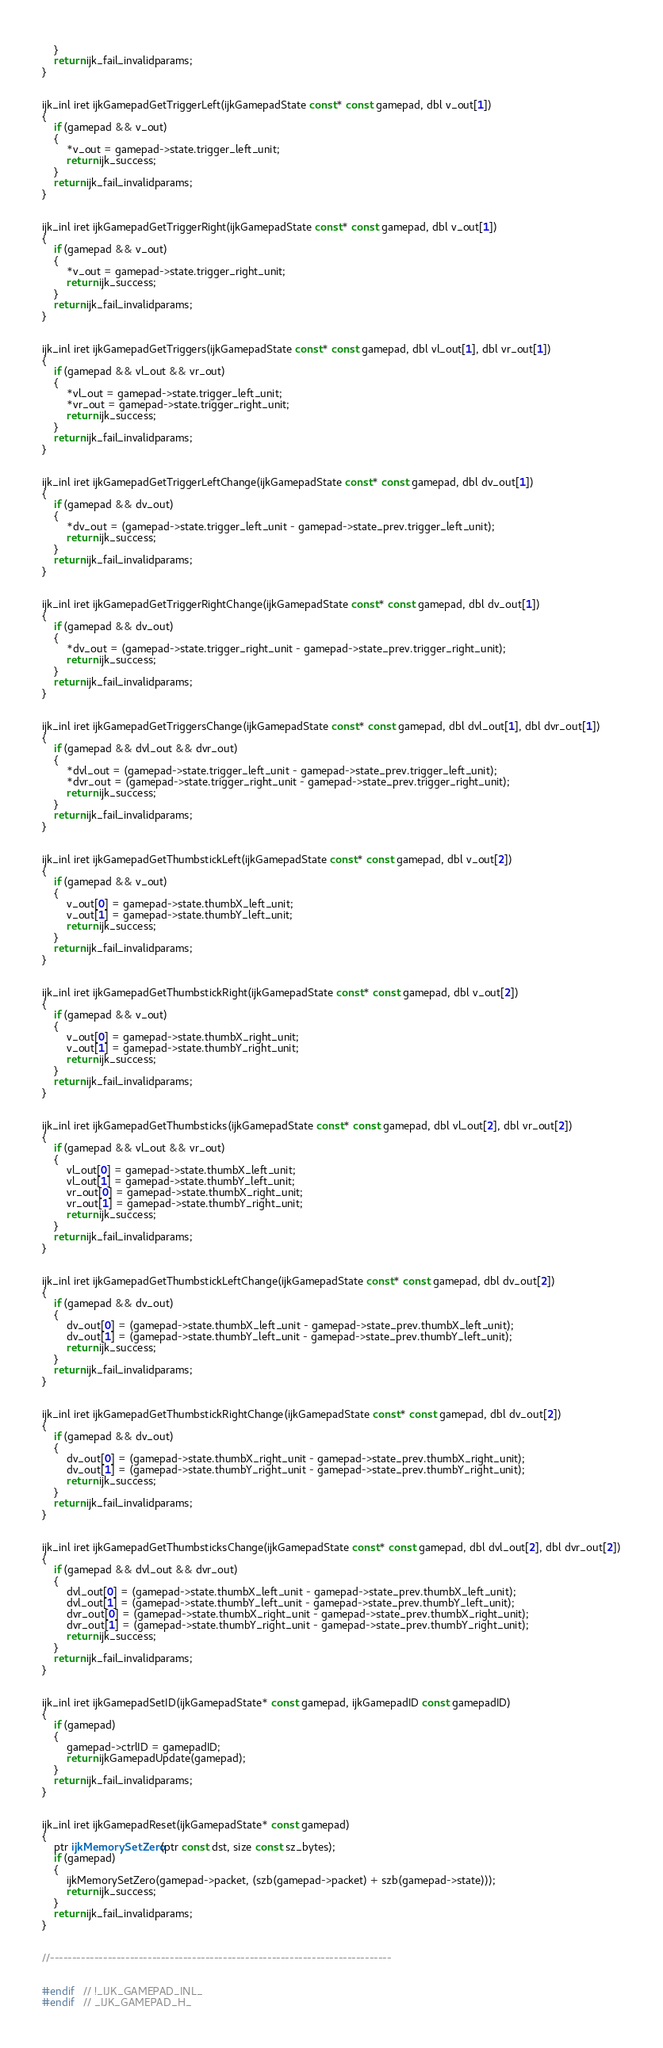<code> <loc_0><loc_0><loc_500><loc_500><_C++_>	}
	return ijk_fail_invalidparams;
}


ijk_inl iret ijkGamepadGetTriggerLeft(ijkGamepadState const* const gamepad, dbl v_out[1])
{
	if (gamepad && v_out)
	{
		*v_out = gamepad->state.trigger_left_unit;
		return ijk_success;
	}
	return ijk_fail_invalidparams;
}


ijk_inl iret ijkGamepadGetTriggerRight(ijkGamepadState const* const gamepad, dbl v_out[1])
{
	if (gamepad && v_out)
	{
		*v_out = gamepad->state.trigger_right_unit;
		return ijk_success;
	}
	return ijk_fail_invalidparams;
}


ijk_inl iret ijkGamepadGetTriggers(ijkGamepadState const* const gamepad, dbl vl_out[1], dbl vr_out[1])
{
	if (gamepad && vl_out && vr_out)
	{
		*vl_out = gamepad->state.trigger_left_unit;
		*vr_out = gamepad->state.trigger_right_unit;
		return ijk_success;
	}
	return ijk_fail_invalidparams;
}


ijk_inl iret ijkGamepadGetTriggerLeftChange(ijkGamepadState const* const gamepad, dbl dv_out[1])
{
	if (gamepad && dv_out)
	{
		*dv_out = (gamepad->state.trigger_left_unit - gamepad->state_prev.trigger_left_unit);
		return ijk_success;
	}
	return ijk_fail_invalidparams;
}


ijk_inl iret ijkGamepadGetTriggerRightChange(ijkGamepadState const* const gamepad, dbl dv_out[1])
{
	if (gamepad && dv_out)
	{
		*dv_out = (gamepad->state.trigger_right_unit - gamepad->state_prev.trigger_right_unit);
		return ijk_success;
	}
	return ijk_fail_invalidparams;
}


ijk_inl iret ijkGamepadGetTriggersChange(ijkGamepadState const* const gamepad, dbl dvl_out[1], dbl dvr_out[1])
{
	if (gamepad && dvl_out && dvr_out)
	{
		*dvl_out = (gamepad->state.trigger_left_unit - gamepad->state_prev.trigger_left_unit);
		*dvr_out = (gamepad->state.trigger_right_unit - gamepad->state_prev.trigger_right_unit);
		return ijk_success;
	}
	return ijk_fail_invalidparams;
}


ijk_inl iret ijkGamepadGetThumbstickLeft(ijkGamepadState const* const gamepad, dbl v_out[2])
{
	if (gamepad && v_out)
	{
		v_out[0] = gamepad->state.thumbX_left_unit;
		v_out[1] = gamepad->state.thumbY_left_unit;
		return ijk_success;
	}
	return ijk_fail_invalidparams;
}


ijk_inl iret ijkGamepadGetThumbstickRight(ijkGamepadState const* const gamepad, dbl v_out[2])
{
	if (gamepad && v_out)
	{
		v_out[0] = gamepad->state.thumbX_right_unit;
		v_out[1] = gamepad->state.thumbY_right_unit;
		return ijk_success;
	}
	return ijk_fail_invalidparams;
}


ijk_inl iret ijkGamepadGetThumbsticks(ijkGamepadState const* const gamepad, dbl vl_out[2], dbl vr_out[2])
{
	if (gamepad && vl_out && vr_out)
	{
		vl_out[0] = gamepad->state.thumbX_left_unit;
		vl_out[1] = gamepad->state.thumbY_left_unit;
		vr_out[0] = gamepad->state.thumbX_right_unit;
		vr_out[1] = gamepad->state.thumbY_right_unit;
		return ijk_success;
	}
	return ijk_fail_invalidparams;
}


ijk_inl iret ijkGamepadGetThumbstickLeftChange(ijkGamepadState const* const gamepad, dbl dv_out[2])
{
	if (gamepad && dv_out)
	{
		dv_out[0] = (gamepad->state.thumbX_left_unit - gamepad->state_prev.thumbX_left_unit);
		dv_out[1] = (gamepad->state.thumbY_left_unit - gamepad->state_prev.thumbY_left_unit);
		return ijk_success;
	}
	return ijk_fail_invalidparams;
}


ijk_inl iret ijkGamepadGetThumbstickRightChange(ijkGamepadState const* const gamepad, dbl dv_out[2])
{
	if (gamepad && dv_out)
	{
		dv_out[0] = (gamepad->state.thumbX_right_unit - gamepad->state_prev.thumbX_right_unit);
		dv_out[1] = (gamepad->state.thumbY_right_unit - gamepad->state_prev.thumbY_right_unit);
		return ijk_success;
	}
	return ijk_fail_invalidparams;
}


ijk_inl iret ijkGamepadGetThumbsticksChange(ijkGamepadState const* const gamepad, dbl dvl_out[2], dbl dvr_out[2])
{
	if (gamepad && dvl_out && dvr_out)
	{
		dvl_out[0] = (gamepad->state.thumbX_left_unit - gamepad->state_prev.thumbX_left_unit);
		dvl_out[1] = (gamepad->state.thumbY_left_unit - gamepad->state_prev.thumbY_left_unit);
		dvr_out[0] = (gamepad->state.thumbX_right_unit - gamepad->state_prev.thumbX_right_unit);
		dvr_out[1] = (gamepad->state.thumbY_right_unit - gamepad->state_prev.thumbY_right_unit);
		return ijk_success;
	}
	return ijk_fail_invalidparams;
}


ijk_inl iret ijkGamepadSetID(ijkGamepadState* const gamepad, ijkGamepadID const gamepadID)
{
	if (gamepad)
	{
		gamepad->ctrlID = gamepadID;
		return ijkGamepadUpdate(gamepad);
	}
	return ijk_fail_invalidparams;
}


ijk_inl iret ijkGamepadReset(ijkGamepadState* const gamepad)
{
	ptr ijkMemorySetZero(ptr const dst, size const sz_bytes);
	if (gamepad)
	{
		ijkMemorySetZero(gamepad->packet, (szb(gamepad->packet) + szb(gamepad->state)));
		return ijk_success;
	}
	return ijk_fail_invalidparams;
}


//-----------------------------------------------------------------------------


#endif	// !_IJK_GAMEPAD_INL_
#endif	// _IJK_GAMEPAD_H_</code> 